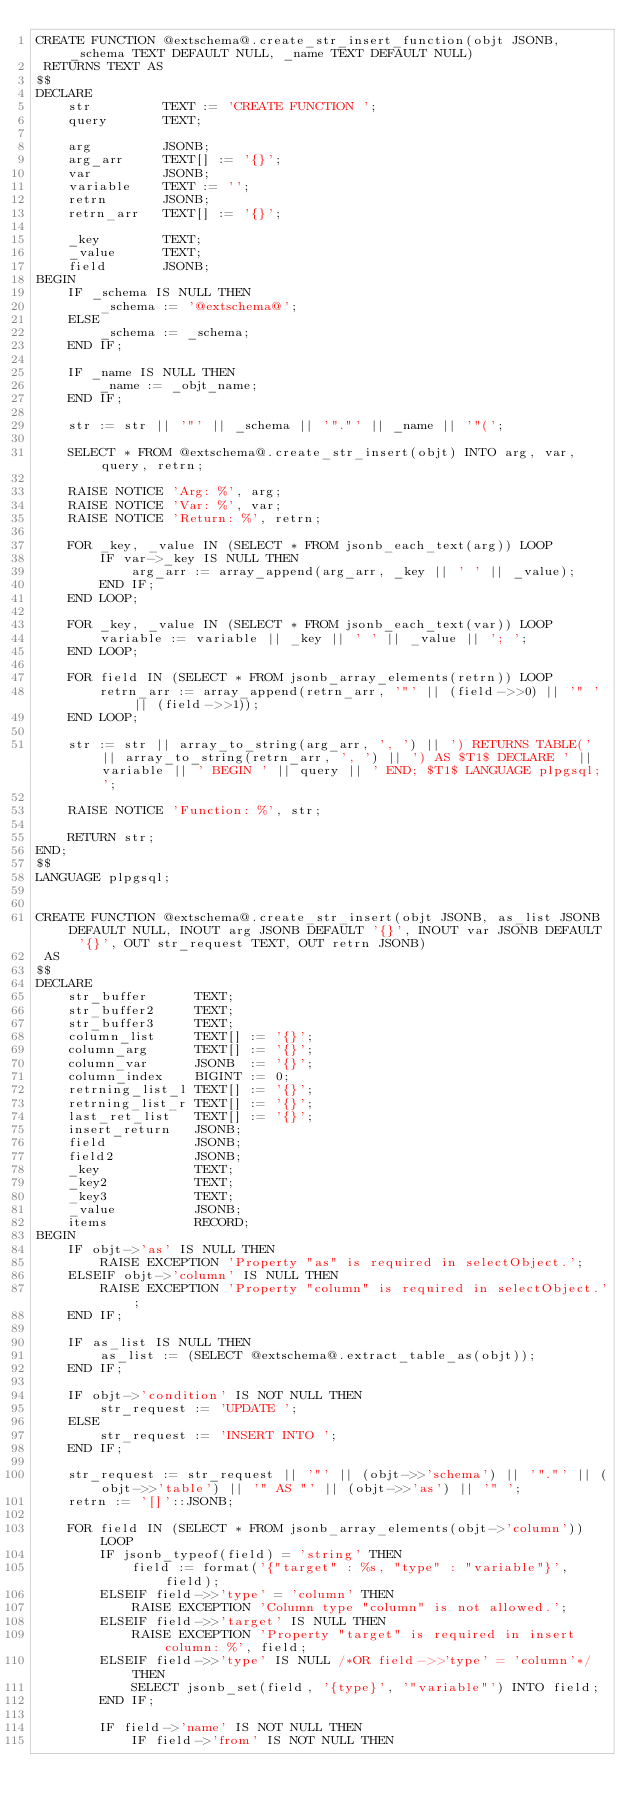<code> <loc_0><loc_0><loc_500><loc_500><_SQL_>CREATE FUNCTION @extschema@.create_str_insert_function(objt JSONB, _schema TEXT DEFAULT NULL, _name TEXT DEFAULT NULL)
 RETURNS TEXT AS
$$
DECLARE
	str 	 	TEXT := 'CREATE FUNCTION ';
	query 	 	TEXT;
	
	arg		 	JSONB;
	arg_arr		TEXT[] := '{}';
	var			JSONB;
	variable	TEXT := '';
	retrn	 	JSONB;
	retrn_arr 	TEXT[] := '{}';
	
	_key		TEXT;
	_value	 	TEXT;
	field	 	JSONB;
BEGIN
	IF _schema IS NULL THEN
		_schema := '@extschema@';
	ELSE
		_schema := _schema;
	END IF;
	
	IF _name IS NULL THEN
		_name := _objt_name;
	END IF;
	
	str := str || '"' || _schema || '"."' || _name || '"(';
	
	SELECT * FROM @extschema@.create_str_insert(objt) INTO arg, var, query, retrn;
	
	RAISE NOTICE 'Arg: %', arg;
	RAISE NOTICE 'Var: %', var;
	RAISE NOTICE 'Return: %', retrn;
	
	FOR _key, _value IN (SELECT * FROM jsonb_each_text(arg)) LOOP
		IF var->_key IS NULL THEN
			arg_arr := array_append(arg_arr, _key || ' ' || _value);
		END IF;
	END LOOP;
	
	FOR _key, _value IN (SELECT * FROM jsonb_each_text(var)) LOOP
		variable := variable || _key || ' ' || _value || '; ';
	END LOOP;
	
	FOR field IN (SELECT * FROM jsonb_array_elements(retrn)) LOOP
		retrn_arr := array_append(retrn_arr, '"' || (field->>0) || '" ' || (field->>1));
	END LOOP;
	
	str := str || array_to_string(arg_arr, ', ') || ') RETURNS TABLE(' || array_to_string(retrn_arr, ', ') || ') AS $T1$ DECLARE ' || variable || ' BEGIN ' || query || ' END; $T1$ LANGUAGE plpgsql;';
	
	RAISE NOTICE 'Function: %', str;
	
	RETURN str;
END;
$$
LANGUAGE plpgsql;


CREATE FUNCTION @extschema@.create_str_insert(objt JSONB, as_list JSONB DEFAULT NULL, INOUT arg JSONB DEFAULT '{}', INOUT var JSONB DEFAULT '{}', OUT str_request TEXT, OUT retrn JSONB)
 AS
$$
DECLARE
	str_buffer		TEXT;
	str_buffer2		TEXT;
	str_buffer3		TEXT;
	column_list 	TEXT[] := '{}';
	column_arg 		TEXT[] := '{}';
	column_var		JSONB  := '{}';
	column_index	BIGINT := 0;
	retrning_list_l	TEXT[] := '{}';
	retrning_list_r	TEXT[] := '{}';
	last_ret_list	TEXT[] := '{}';
	insert_return	JSONB;
	field 			JSONB;
	field2 			JSONB;
	_key			TEXT;
	_key2			TEXT;
	_key3			TEXT;
	_value			JSONB;
	items			RECORD;
BEGIN
	IF objt->'as' IS NULL THEN
		RAISE EXCEPTION 'Property "as" is required in selectObject.';
	ELSEIF objt->'column' IS NULL THEN
		RAISE EXCEPTION 'Property "column" is required in selectObject.';
	END IF;
	
	IF as_list IS NULL THEN
		as_list := (SELECT @extschema@.extract_table_as(objt));
	END IF;
	
	IF objt->'condition' IS NOT NULL THEN
		str_request := 'UPDATE ';
	ELSE
		str_request := 'INSERT INTO ';
	END IF;
	
	str_request := str_request || '"' || (objt->>'schema') || '"."' || (objt->>'table') || '" AS "' || (objt->>'as') || '" ';
	retrn := '[]'::JSONB;
	
	FOR field IN (SELECT * FROM jsonb_array_elements(objt->'column')) LOOP
		IF jsonb_typeof(field) = 'string' THEN
			field := format('{"target" : %s, "type" : "variable"}', field);
		ELSEIF field->>'type' = 'column' THEN
			RAISE EXCEPTION 'Column type "column" is not allowed.';
		ELSEIF field->>'target' IS NULL THEN
			RAISE EXCEPTION 'Property "target" is required in insert column: %', field;
		ELSEIF field->>'type' IS NULL /*OR field->>'type' = 'column'*/ THEN
			SELECT jsonb_set(field, '{type}', '"variable"') INTO field;
		END IF;
		
		IF field->'name' IS NOT NULL THEN
			IF field->'from' IS NOT NULL THEN</code> 